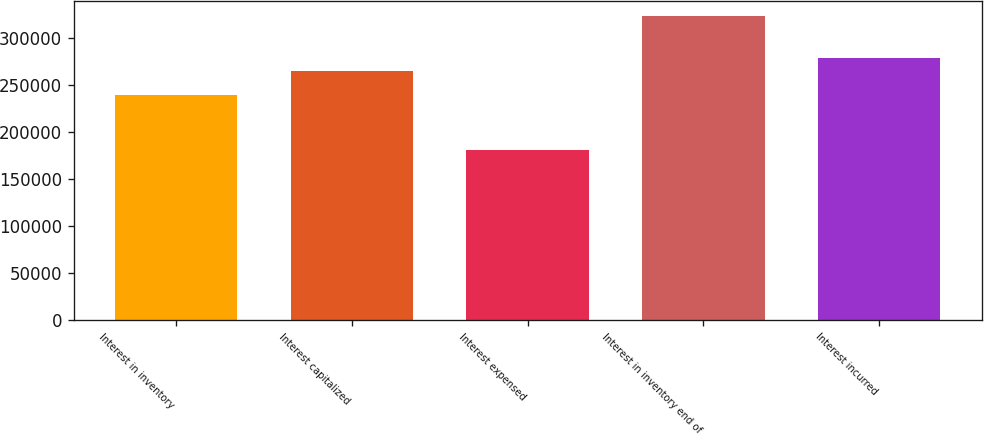Convert chart. <chart><loc_0><loc_0><loc_500><loc_500><bar_chart><fcel>Interest in inventory<fcel>Interest capitalized<fcel>Interest expensed<fcel>Interest in inventory end of<fcel>Interest incurred<nl><fcel>239365<fcel>264932<fcel>180918<fcel>323379<fcel>279178<nl></chart> 